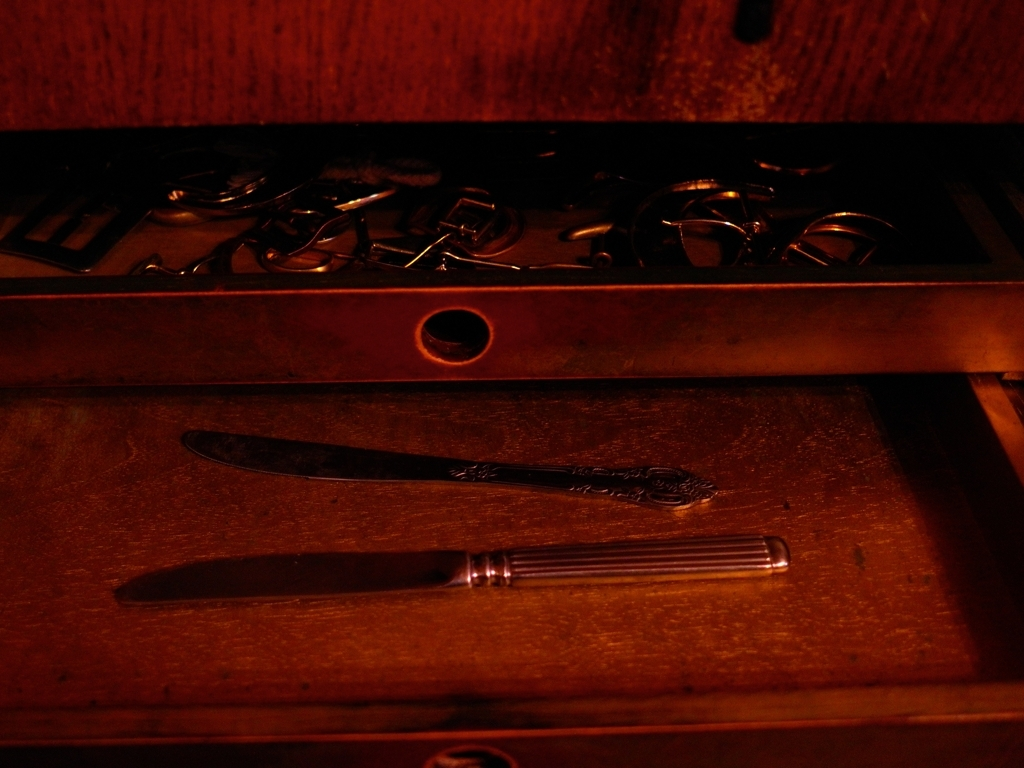Is the color rendering accurate in the image? While it's difficult for me to determine accuracy without knowing the real-life colors, the image appears to have a warm tone, with reds and oranges that suggest it might be artificially tinted or taken under warm lighting. This could affect the perceived accuracy of the colors in the image. 